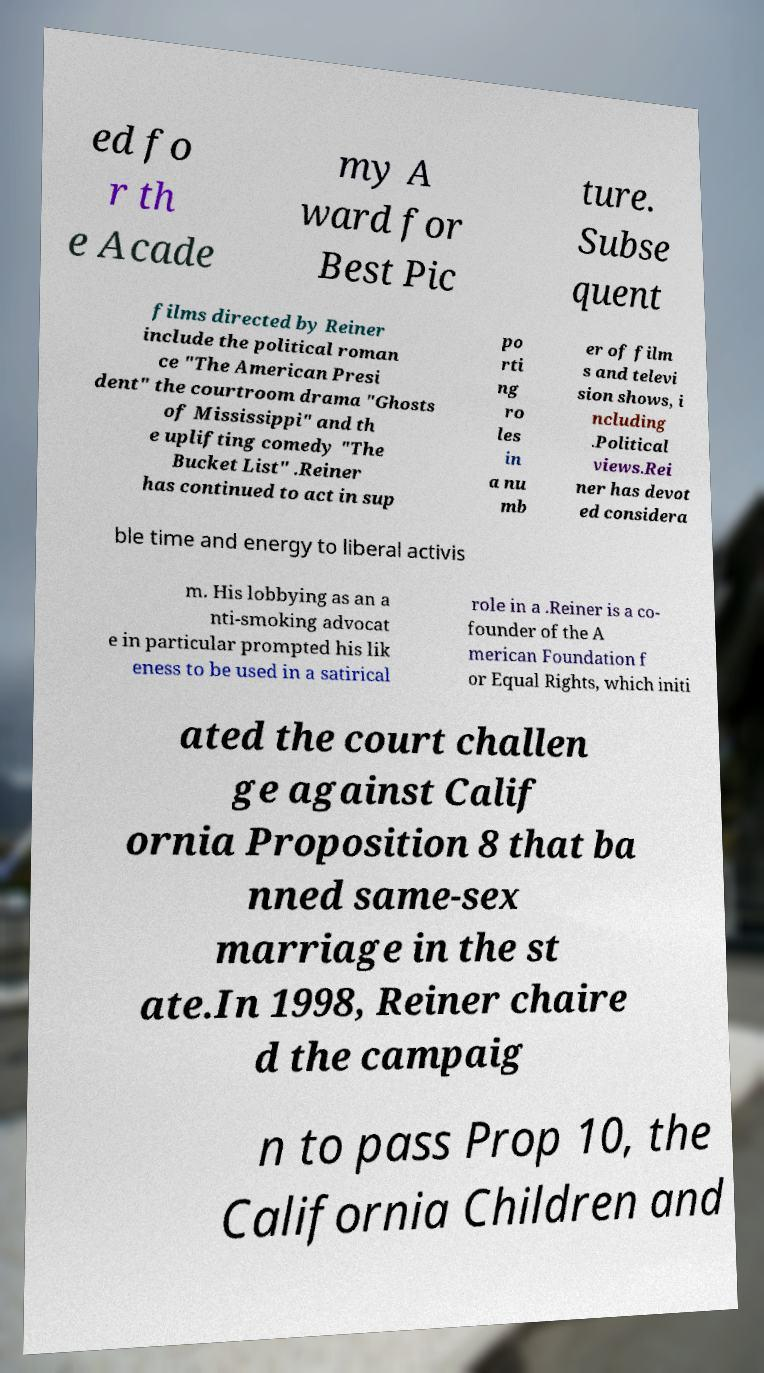Can you accurately transcribe the text from the provided image for me? ed fo r th e Acade my A ward for Best Pic ture. Subse quent films directed by Reiner include the political roman ce "The American Presi dent" the courtroom drama "Ghosts of Mississippi" and th e uplifting comedy "The Bucket List" .Reiner has continued to act in sup po rti ng ro les in a nu mb er of film s and televi sion shows, i ncluding .Political views.Rei ner has devot ed considera ble time and energy to liberal activis m. His lobbying as an a nti-smoking advocat e in particular prompted his lik eness to be used in a satirical role in a .Reiner is a co- founder of the A merican Foundation f or Equal Rights, which initi ated the court challen ge against Calif ornia Proposition 8 that ba nned same-sex marriage in the st ate.In 1998, Reiner chaire d the campaig n to pass Prop 10, the California Children and 